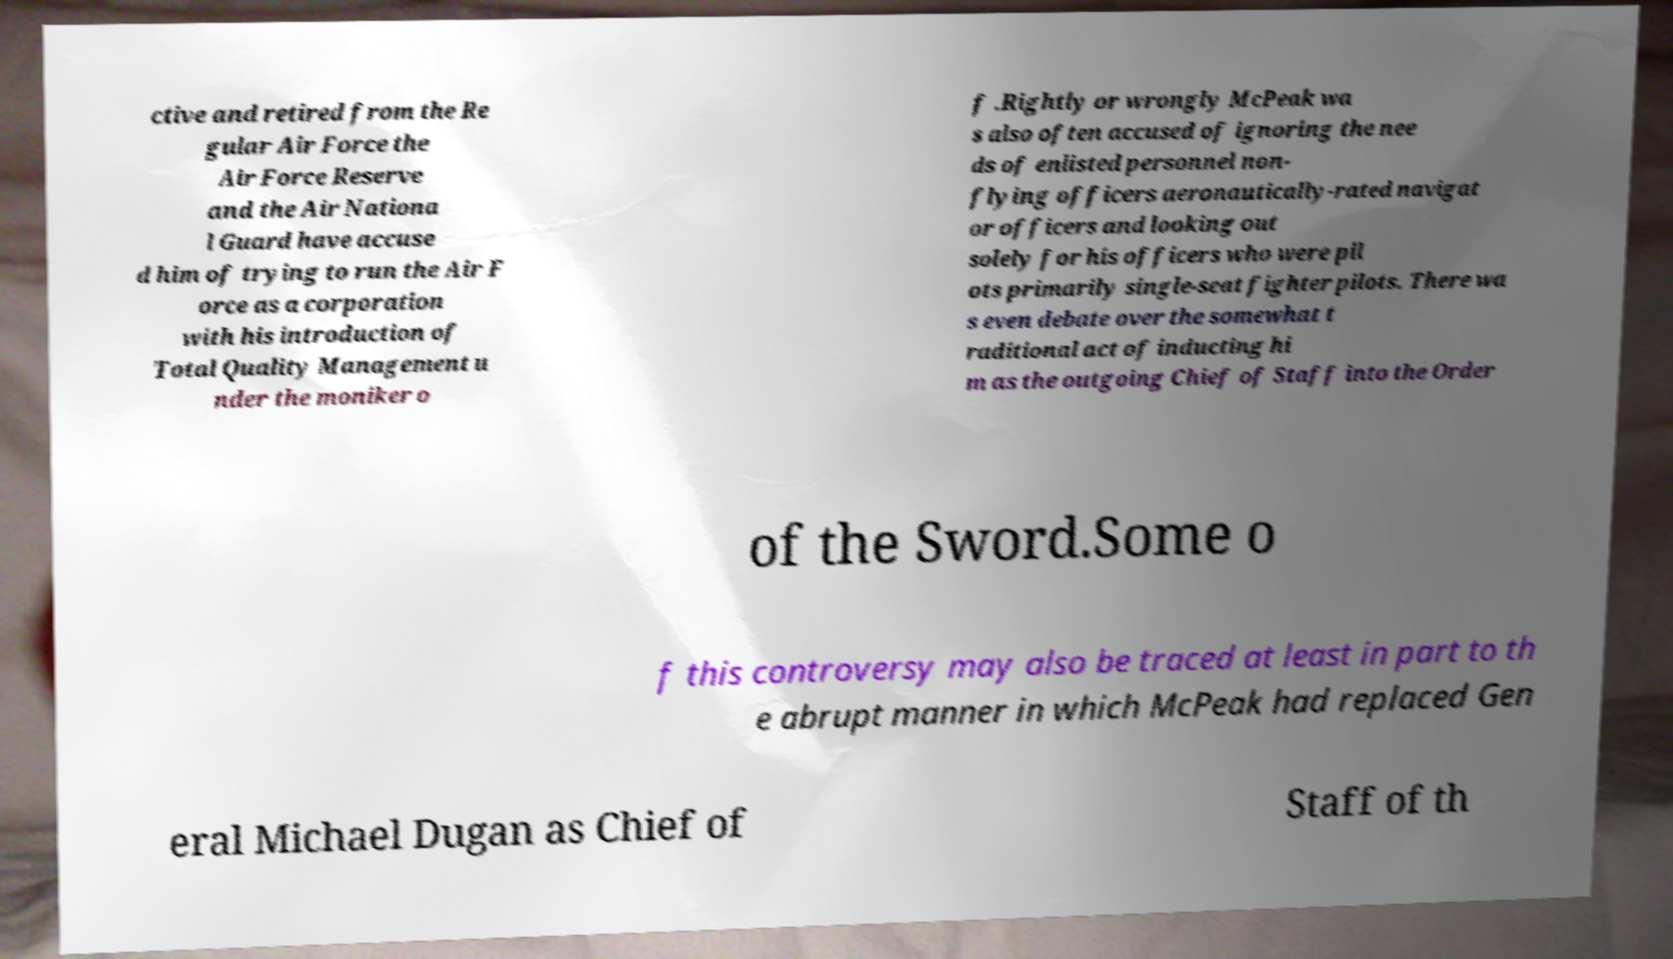Please read and relay the text visible in this image. What does it say? ctive and retired from the Re gular Air Force the Air Force Reserve and the Air Nationa l Guard have accuse d him of trying to run the Air F orce as a corporation with his introduction of Total Quality Management u nder the moniker o f .Rightly or wrongly McPeak wa s also often accused of ignoring the nee ds of enlisted personnel non- flying officers aeronautically-rated navigat or officers and looking out solely for his officers who were pil ots primarily single-seat fighter pilots. There wa s even debate over the somewhat t raditional act of inducting hi m as the outgoing Chief of Staff into the Order of the Sword.Some o f this controversy may also be traced at least in part to th e abrupt manner in which McPeak had replaced Gen eral Michael Dugan as Chief of Staff of th 